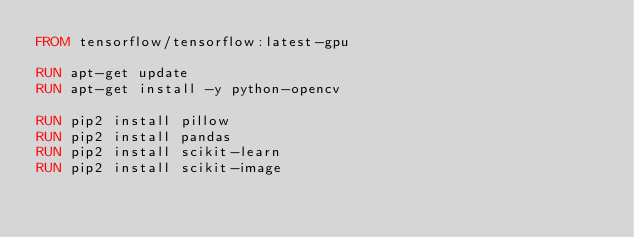Convert code to text. <code><loc_0><loc_0><loc_500><loc_500><_Dockerfile_>FROM tensorflow/tensorflow:latest-gpu

RUN apt-get update
RUN apt-get install -y python-opencv

RUN pip2 install pillow
RUN pip2 install pandas
RUN pip2 install scikit-learn
RUN pip2 install scikit-image


</code> 